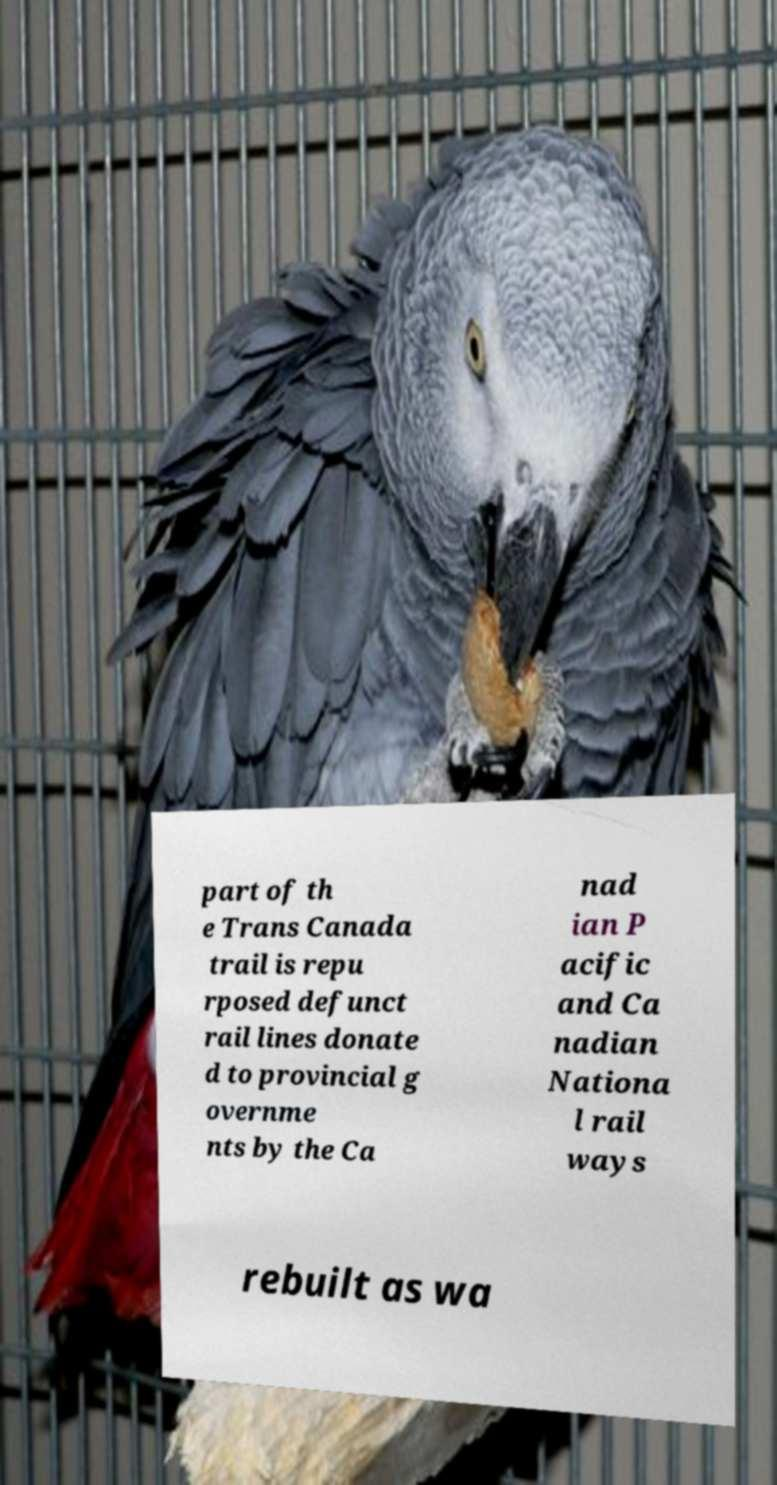Could you assist in decoding the text presented in this image and type it out clearly? part of th e Trans Canada trail is repu rposed defunct rail lines donate d to provincial g overnme nts by the Ca nad ian P acific and Ca nadian Nationa l rail ways rebuilt as wa 